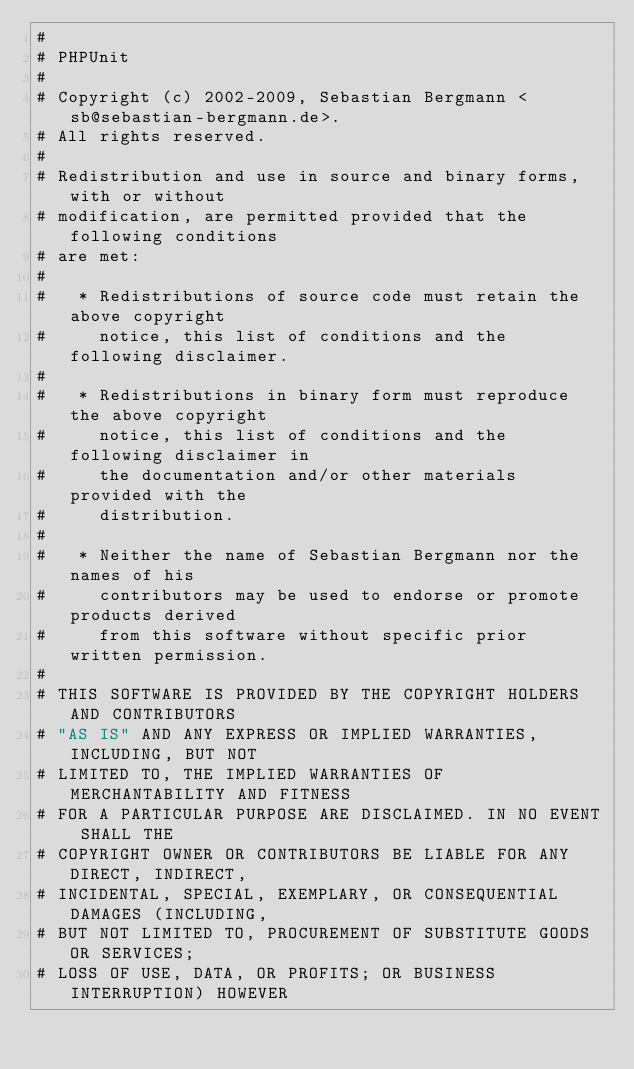<code> <loc_0><loc_0><loc_500><loc_500><_SQL_>#
# PHPUnit
#
# Copyright (c) 2002-2009, Sebastian Bergmann <sb@sebastian-bergmann.de>.
# All rights reserved.
#
# Redistribution and use in source and binary forms, with or without
# modification, are permitted provided that the following conditions
# are met:
#
#   * Redistributions of source code must retain the above copyright
#     notice, this list of conditions and the following disclaimer.
#
#   * Redistributions in binary form must reproduce the above copyright
#     notice, this list of conditions and the following disclaimer in
#     the documentation and/or other materials provided with the
#     distribution.
#
#   * Neither the name of Sebastian Bergmann nor the names of his
#     contributors may be used to endorse or promote products derived
#     from this software without specific prior written permission.
#
# THIS SOFTWARE IS PROVIDED BY THE COPYRIGHT HOLDERS AND CONTRIBUTORS
# "AS IS" AND ANY EXPRESS OR IMPLIED WARRANTIES, INCLUDING, BUT NOT
# LIMITED TO, THE IMPLIED WARRANTIES OF MERCHANTABILITY AND FITNESS
# FOR A PARTICULAR PURPOSE ARE DISCLAIMED. IN NO EVENT SHALL THE
# COPYRIGHT OWNER OR CONTRIBUTORS BE LIABLE FOR ANY DIRECT, INDIRECT,
# INCIDENTAL, SPECIAL, EXEMPLARY, OR CONSEQUENTIAL DAMAGES (INCLUDING,
# BUT NOT LIMITED TO, PROCUREMENT OF SUBSTITUTE GOODS OR SERVICES;
# LOSS OF USE, DATA, OR PROFITS; OR BUSINESS INTERRUPTION) HOWEVER</code> 